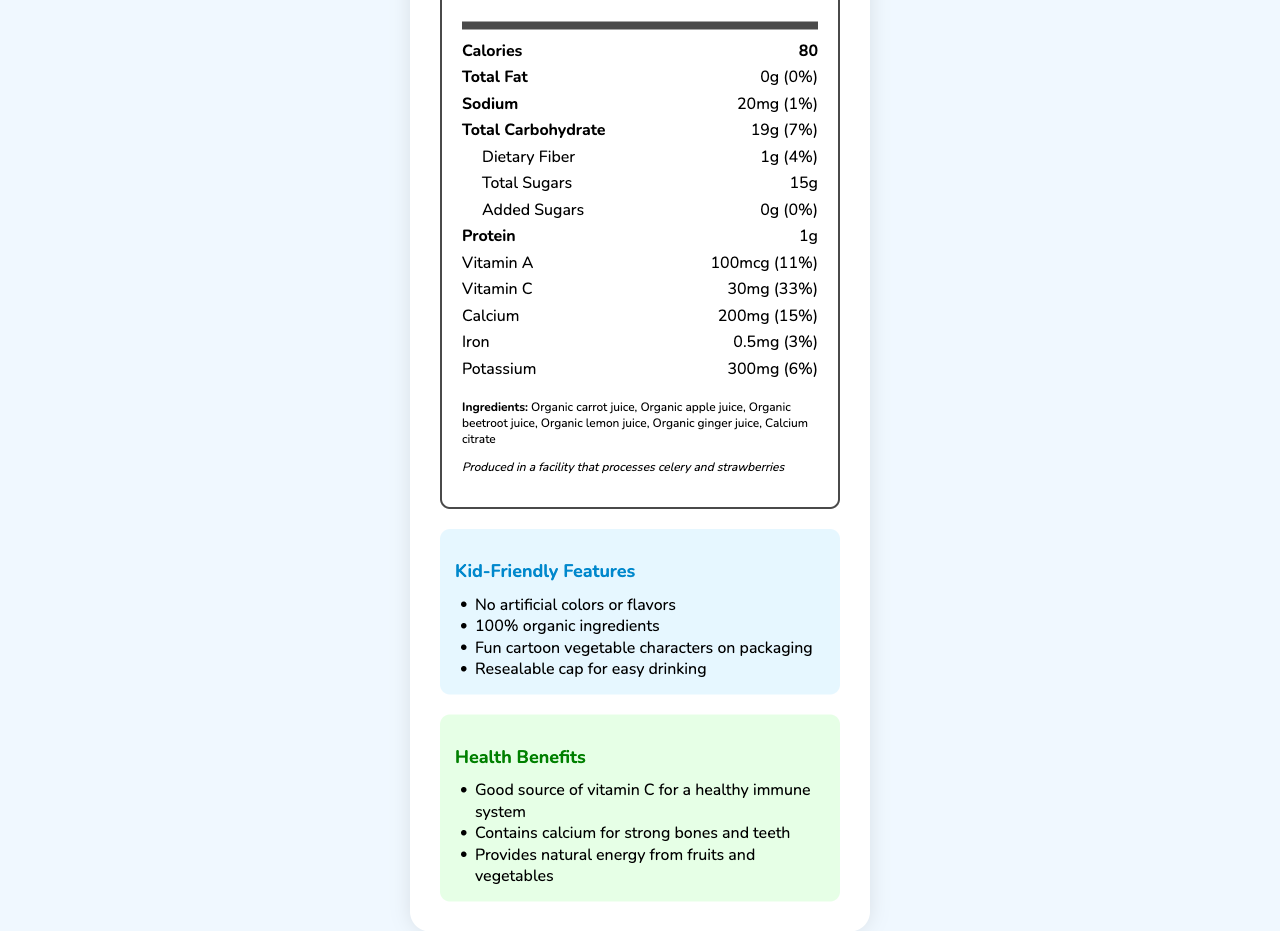how many calories are in one serving? The document states that 1 box (200 ml) contains 80 calories.
Answer: 80 what is the serving size of the Veggie Tales Organic Juice Blend? The document lists the serving size as 1 box (200 ml).
Answer: 1 box (200 ml) how much calcium is in one serving? The document mentions that there is 200mg of calcium per serving.
Answer: 200mg how much total sugar does one serving contain? The document specifies that the total sugar content in one serving is 15g.
Answer: 15g which vitamins are included and in what amounts? The document indicates that the juice contains 100mcg of Vitamin A and 30mg of Vitamin C.
Answer: Vitamin A: 100mcg, Vitamin C: 30mg which ingredient is listed first? The document lists organic carrot juice as the first ingredient.
Answer: Organic carrot juice how should the juice be stored after opening? The document notes that the juice should be kept refrigerated after opening and consumed within 3 days.
Answer: Keep refrigerated and consume within 3 days what is the daily value percentage of Dietary Fiber in one serving? The document lists the daily value of dietary fiber as 4%.
Answer: 4% multiple-choice: how much sodium does one serving contain? A. 10mg B. 20mg C. 30mg D. 40mg The document indicates the sodium content as 20mg per serving.
Answer: B. 20mg multiple-choice: which feature is NOT mentioned as kid-friendly? A. No artificial colors B. 100% organic ingredients C. Fun cartoon vegetable characters on packaging D. Gluten-free The document lists the kid-friendly features, and gluten-free is not one of them.
Answer: D. Gluten-free True or False: The juice contains added sugars. The document specifies that there are 0g of added sugars.
Answer: False summarize the main idea of the document. The document covers the serving size, nutritional values, ingredients, allergen information, kid-friendly features, health benefits, storage instructions, and manufacturer details of the juice.
Answer: Summary: The document provides detailed nutrition facts and features of the Veggie Tales Organic Juice Blend, an organic vegetable juice with added calcium, designed to be kid-friendly and healthy. what is the address of the manufacturer? The document states the manufacturer's address is Happy Kids Organic Foods, 123 Sunshine Lane, Fruitville, CA 90210.
Answer: Happy Kids Organic Foods, 123 Sunshine Lane, Fruitville, CA 90210 how much protein is in one serving of the juice? The document specifies that one serving of the juice contains 1g of protein.
Answer: 1g is the juice blend gluten-free? The document provides various information about the nutritional content and features, but it does not mention if the juice blend is gluten-free.
Answer: Cannot be determined 